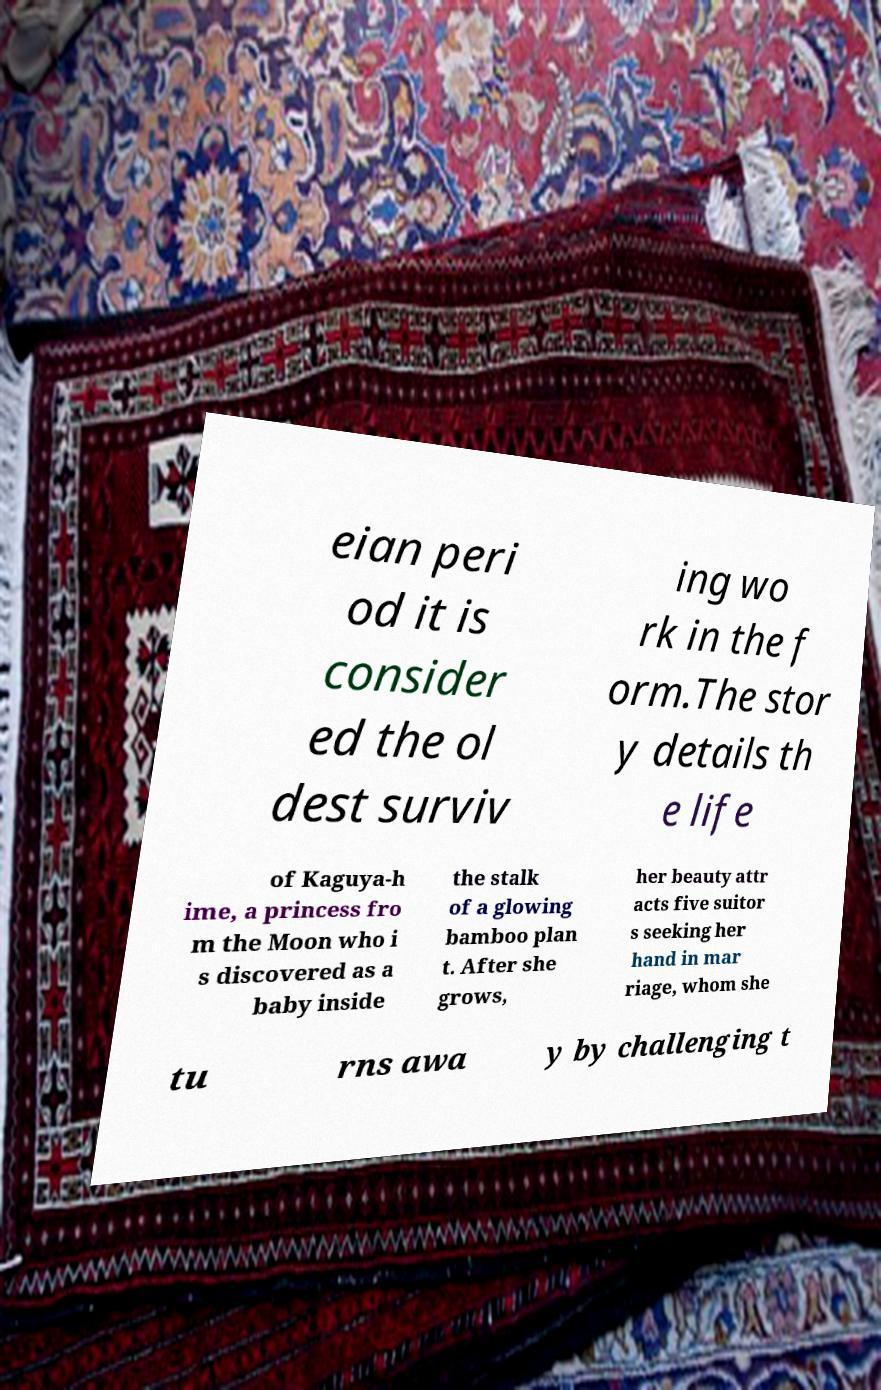Can you read and provide the text displayed in the image?This photo seems to have some interesting text. Can you extract and type it out for me? eian peri od it is consider ed the ol dest surviv ing wo rk in the f orm.The stor y details th e life of Kaguya-h ime, a princess fro m the Moon who i s discovered as a baby inside the stalk of a glowing bamboo plan t. After she grows, her beauty attr acts five suitor s seeking her hand in mar riage, whom she tu rns awa y by challenging t 